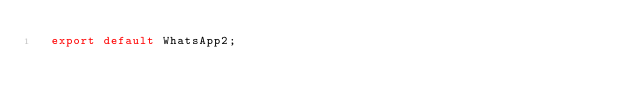Convert code to text. <code><loc_0><loc_0><loc_500><loc_500><_TypeScript_>  export default WhatsApp2;
</code> 